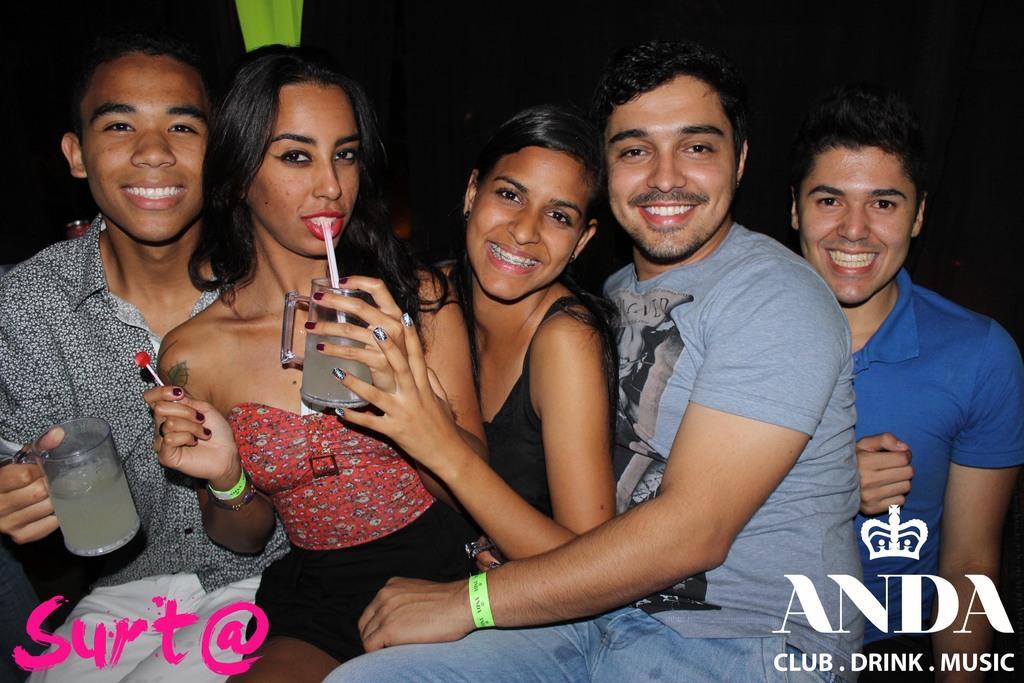Could you give a brief overview of what you see in this image? In this image I can see two women, three men are sitting, smiling and giving pose for the picture. The man who is on the left side is holding a glass in the hand. The woman is also holding a glass. The background is in black color. At the bottom of the image I can see some text. 